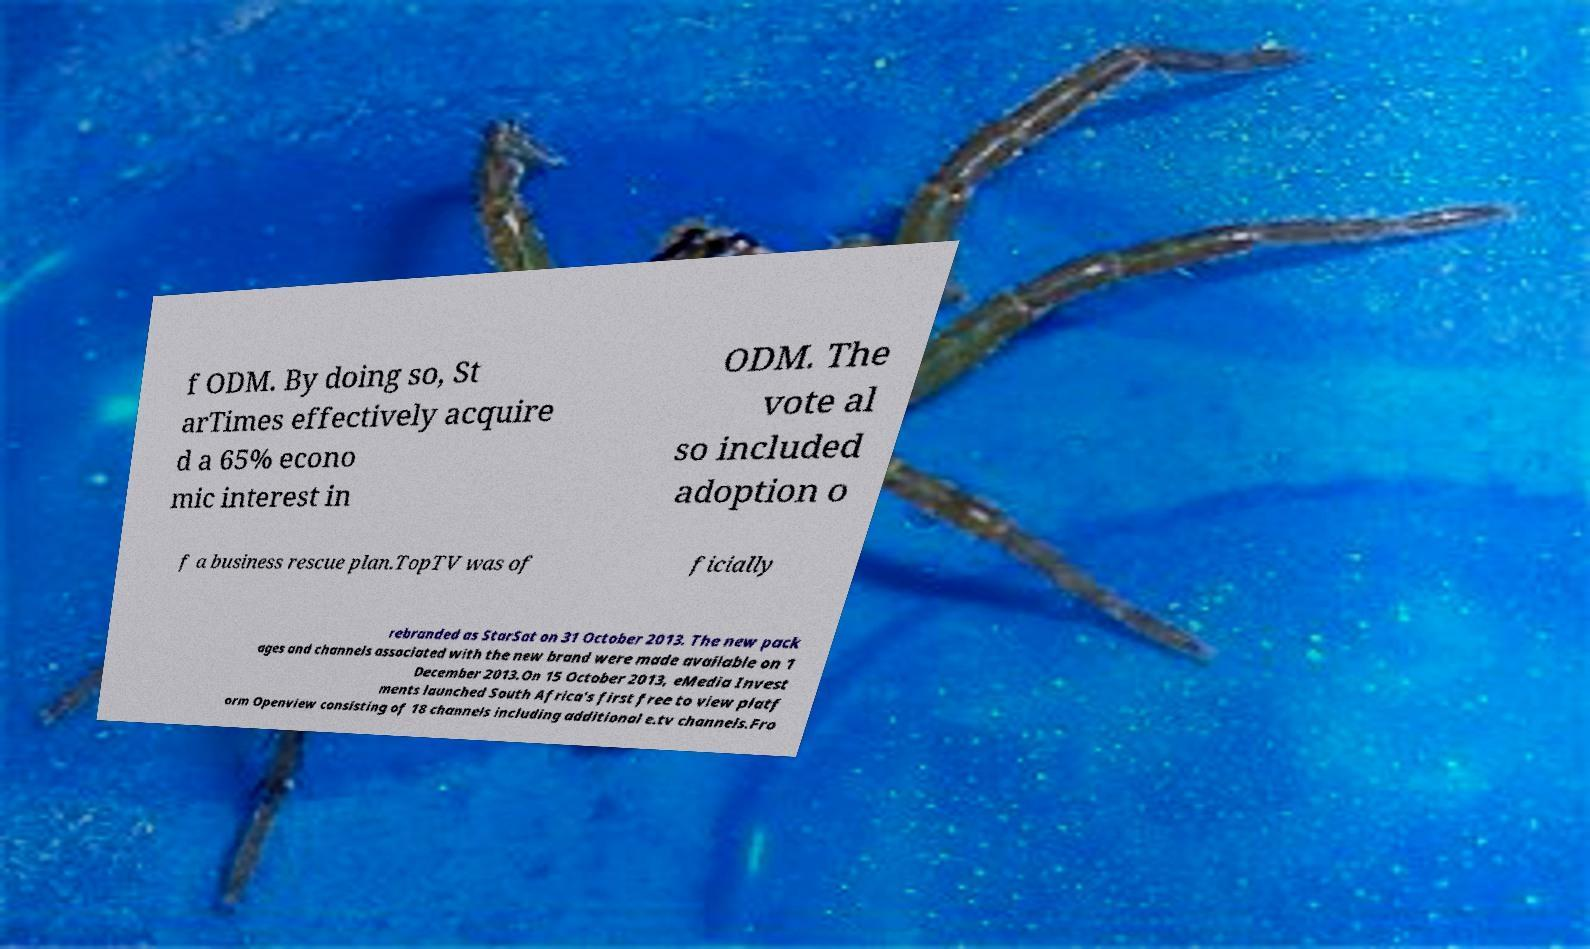Could you extract and type out the text from this image? f ODM. By doing so, St arTimes effectively acquire d a 65% econo mic interest in ODM. The vote al so included adoption o f a business rescue plan.TopTV was of ficially rebranded as StarSat on 31 October 2013. The new pack ages and channels associated with the new brand were made available on 1 December 2013.On 15 October 2013, eMedia Invest ments launched South Africa's first free to view platf orm Openview consisting of 18 channels including additional e.tv channels.Fro 